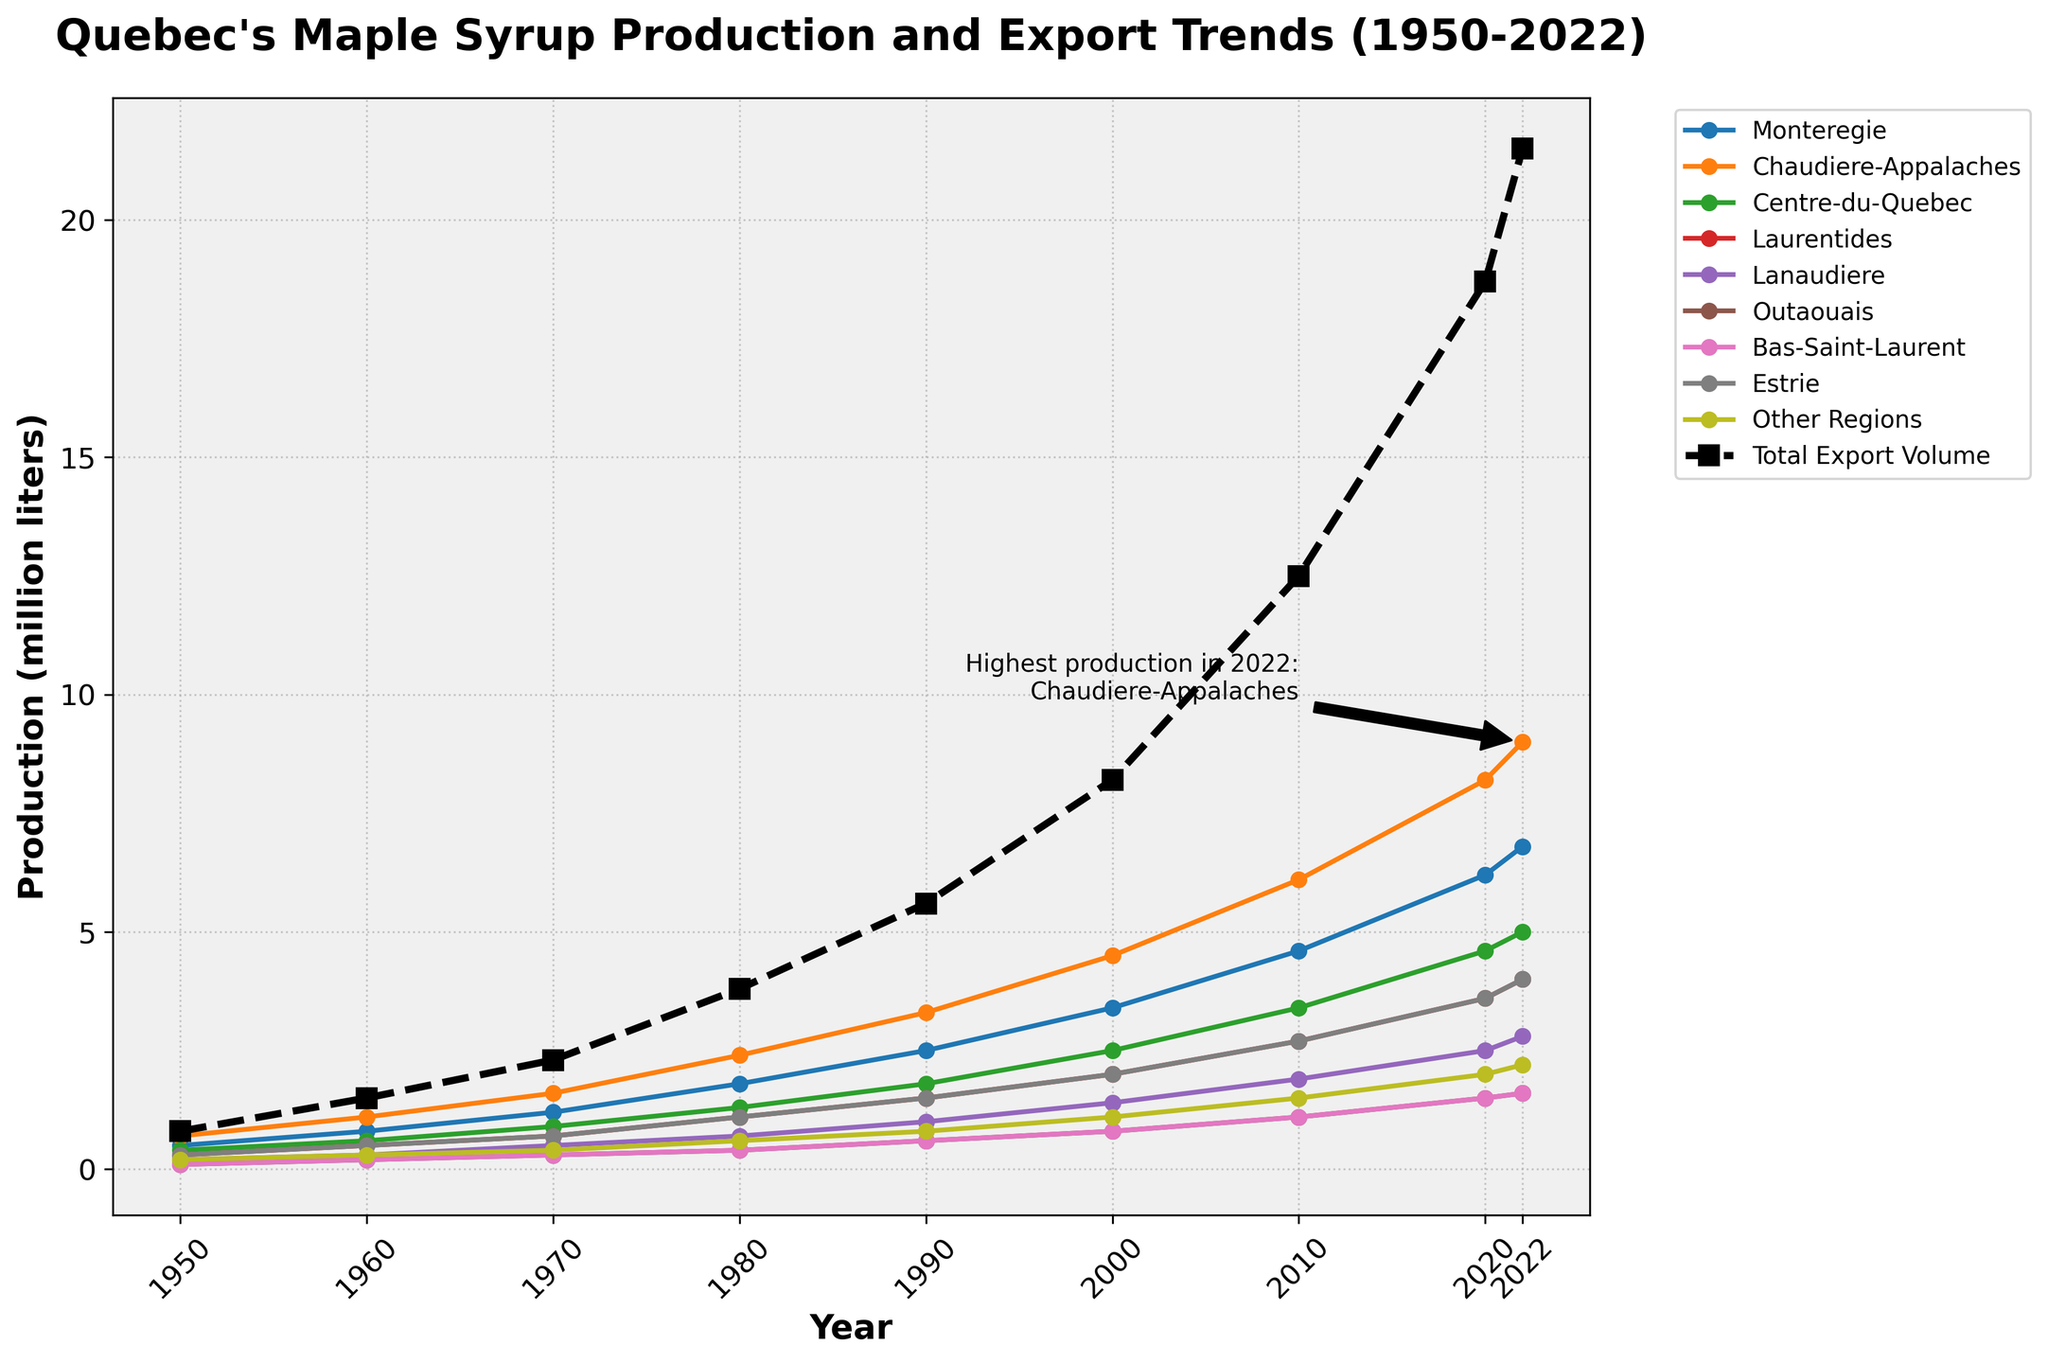Which region had the highest maple syrup production in 2022? By looking at the annotations in the plot and the values for each region in 2022, it's clear the highest production is annotated. Check the label for the highest value in 2022.
Answer: Chaudiere-Appalaches What's the difference in total export volume between 2020 and 2022? Find the values of total export volume for the years 2020 and 2022, then subtract the 2020 value from the 2022 value.
Answer: 2.8 million liters How did the production in Estrie change from 1950 to 2022? Compare the value for Estrie in 1950 with its value in 2022 by examining the line for Estrie and referring to its exact figures in the chart.
Answer: Increased from 0.3 million liters to 4.0 million liters Compare the maple syrup production in Laurentides and Lanaudiere in 1970. Which was higher? Look at the values for Laurentides and Lanaudiere in 1970 and determine which one is greater by comparing their positions on the vertical axis.
Answer: Laurentides (0.7 million liters) Which region had the lowest production in 2022? Identify the lowest value among all the regions for the year 2022 by comparing the vertical positions of the lines at that year.
Answer: Outaouais What was the average production for Monteregie from 1950 to 2022? Add up the production values for Monteregie for all provided years and divide by the number of years (9). (0.5 + 0.8 + 1.2 + 1.8 + 2.5 + 3.4 + 4.6 + 6.2 + 6.8)/9 = 27.8/9 = 3.1
Answer: 3.1 million liters Did Centre-du-Quebec or Bas-Saint-Laurent have a faster growth rate from 2000 to 2022? Determine the production values for Centre-du-Quebec and Bas-Saint-Laurent in 2000 and 2022, then calculate the growth for each region by subtracting 2000 values from 2022 values. Centre-du-Quebec: 5.0 - 2.5 = 2.5; Bas-Saint-Laurent: 1.6 - 0.8 = 0.8
Answer: Centre-du-Quebec What is the total export volume trend from 1950 to 2022? Observe the line representing the total export volume over the years and describe its overall movement, noting how it starts at a lower value and rises steeply towards the end.
Answer: Increasing Which region saw the most significant increase in production between 1990 and 2000? Calculate the increase for each region by subtracting the 1990 values from the 2000 values, and identify the region with the highest difference. Chaudiere-Appalaches: 4.5 - 3.3 = 1.2
Answer: Chaudiere-Appalaches 